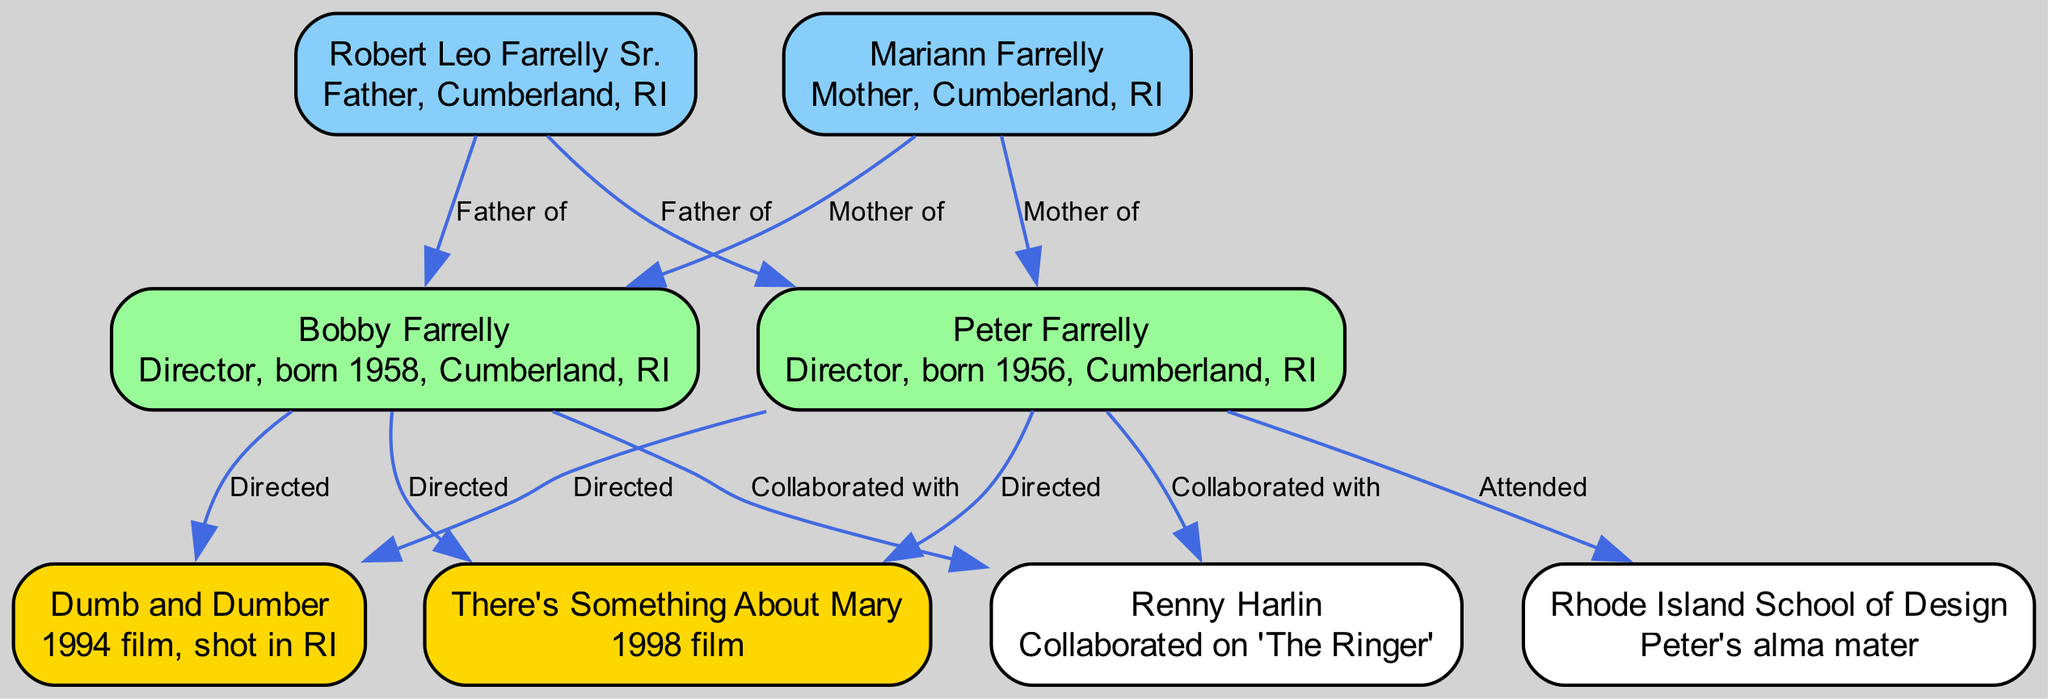What is the name of the mother of Peter Farrelly? According to the diagram, Mariann Farrelly is labeled as the mother of both Peter and Bobby Farrelly, as indicated by the edge connecting her to Peter Farrelly.
Answer: Mariann Farrelly How many films are directed by the Farrelly brothers shown in the diagram? The diagram highlights two films "Dumb and Dumber" and "There's Something About Mary." Both films have directed edges leading from both Peter and Bobby Farrelly. Therefore, we count two films directed by them in the diagram.
Answer: 2 Who is labeled as the father of Bobby Farrelly? The diagram shows Robert Leo Farrelly Sr. with directed edges extending to both Peter and Bobby Farrelly, explicitly labeling him as the father of Bobby Farrelly.
Answer: Robert Leo Farrelly Sr What university did Peter Farrelly attend? The diagram indicates that there is a connection labeled "Attended" between Peter Farrelly and the "Rhode Island School of Design," marking it as the university he attended.
Answer: Rhode Island School of Design Which film listed in the diagram was shot in Rhode Island? The diagram includes "Dumb and Dumber," with a note stating it was shot in Rhode Island, distinguishing it from the other film listed.
Answer: Dumb and Dumber Who collaborated with both Farrelly brothers on "The Ringer"? The node labeled "Renny Harlin" demonstrates his collaborations with both Peter and Bobby Farrelly, indicating that he worked with each on "The Ringer."
Answer: Renny Harlin What is the birth year of Bobby Farrelly? The diagram specifies Bobby Farrelly's details, indicating that he was born in 1958, which can be directly read from the diagram.
Answer: 1958 What type of edge connects Robert Leo Farrelly Sr. to his sons? The edges connecting Robert Leo Farrelly Sr. to both of his sons, Peter and Bobby, are labeled as "Father of," denoting the direct familial relationship.
Answer: Father of How many directed edges are shown for Peter Farrelly? By counting the edges leading from Peter Farrelly, we see he has four: two of which are labeled as "Directed" towards films and one "Attended" edge, plus one "Collaborated with" edge. Thus, there are four directed edges associated with Peter Farrelly.
Answer: 4 